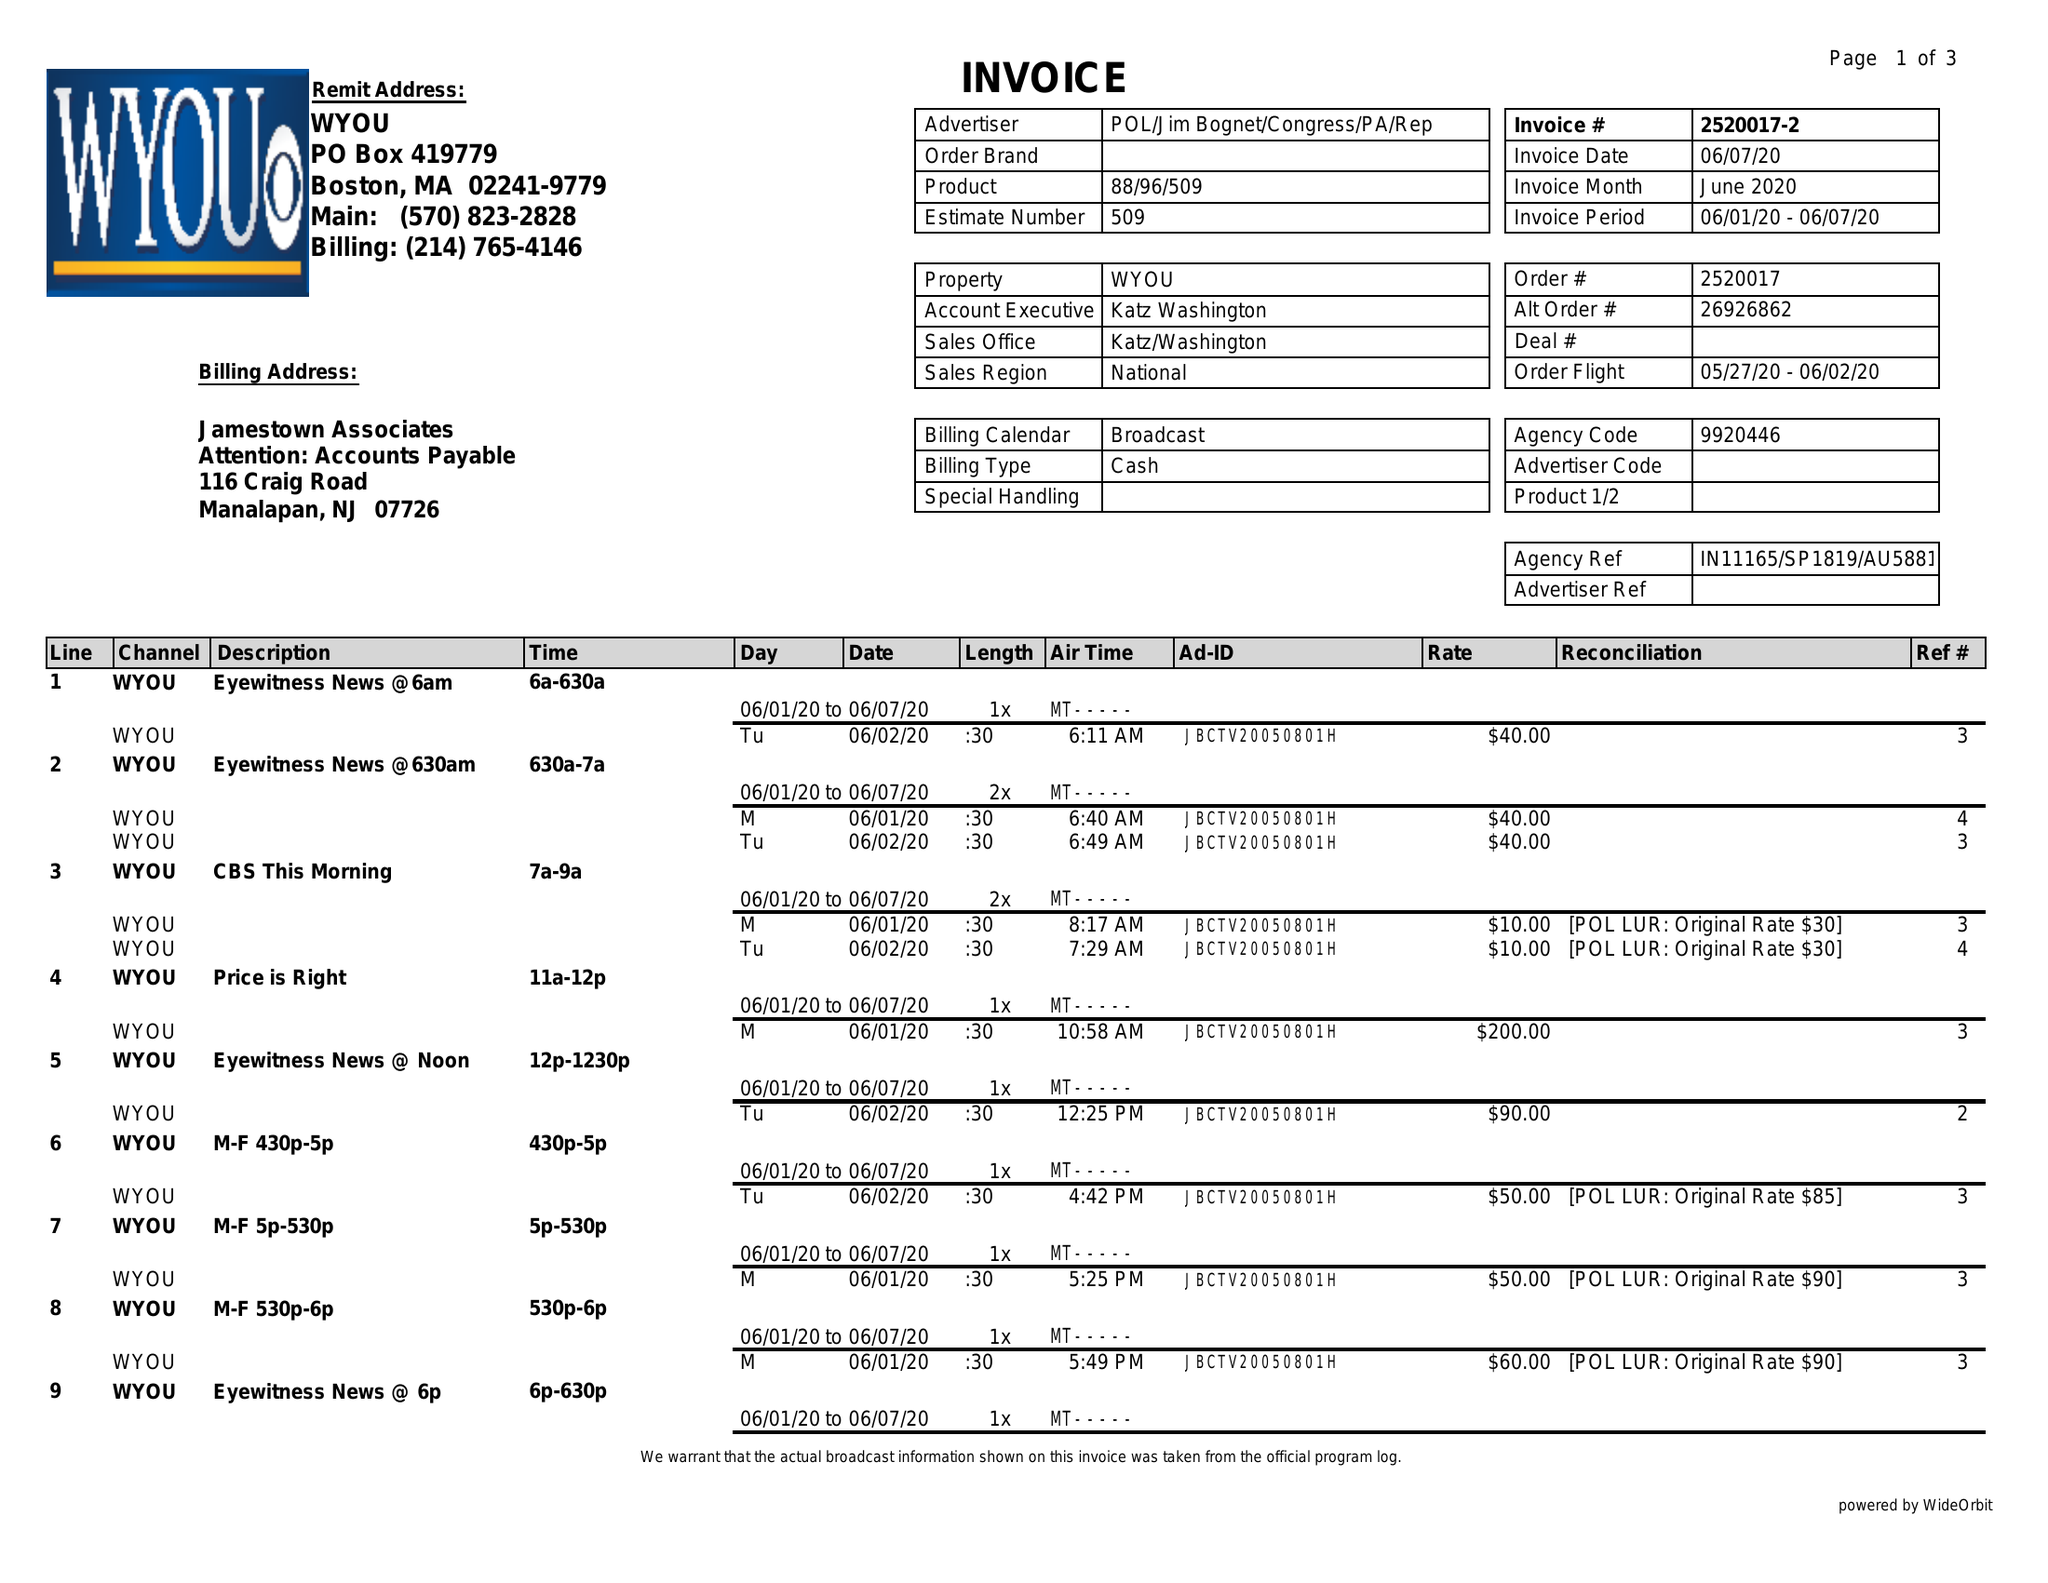What is the value for the flight_to?
Answer the question using a single word or phrase. 06/02/20 